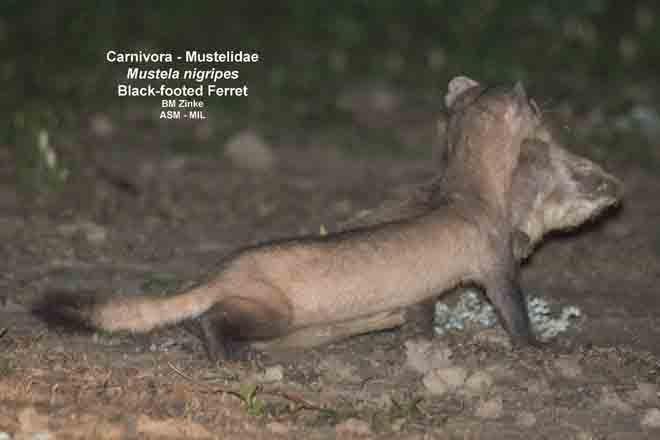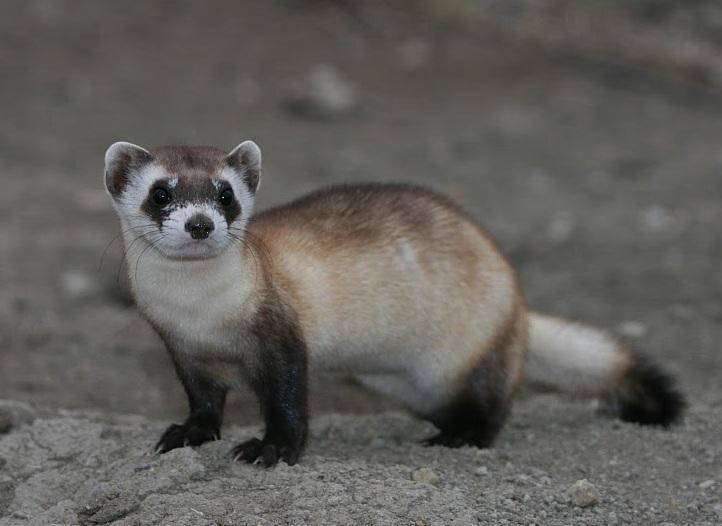The first image is the image on the left, the second image is the image on the right. Assess this claim about the two images: "The animal in the image on the right is in side profile turned toward the left with its face turned toward the camera.". Correct or not? Answer yes or no. Yes. 